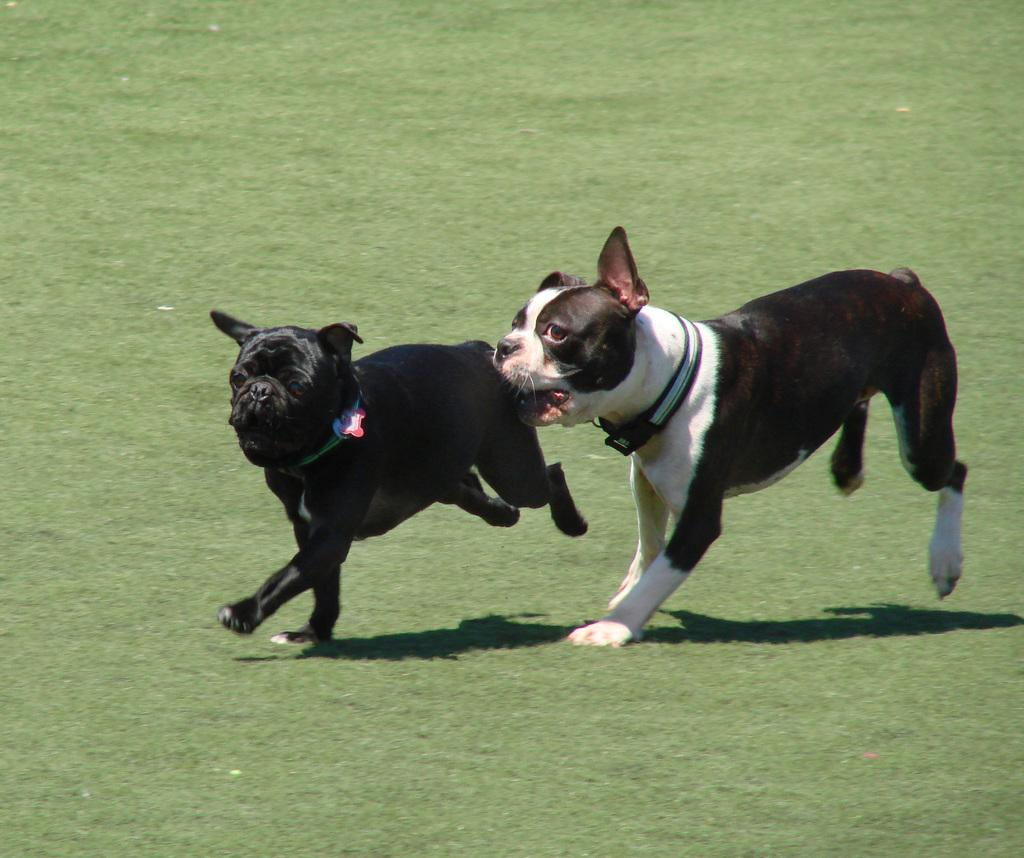What animals can be seen in the image? There are dogs in the image. What are the dogs doing in the image? The dogs are running on the ground. What type of surface are the dogs running on? There is grass in the image, which is the surface the dogs are running on. What line can be seen in the image? There is no line present in the image. What chance do the dogs have of winning a race in the image? The image does not depict a race, so it is impossible to determine the chances of the dogs winning. 